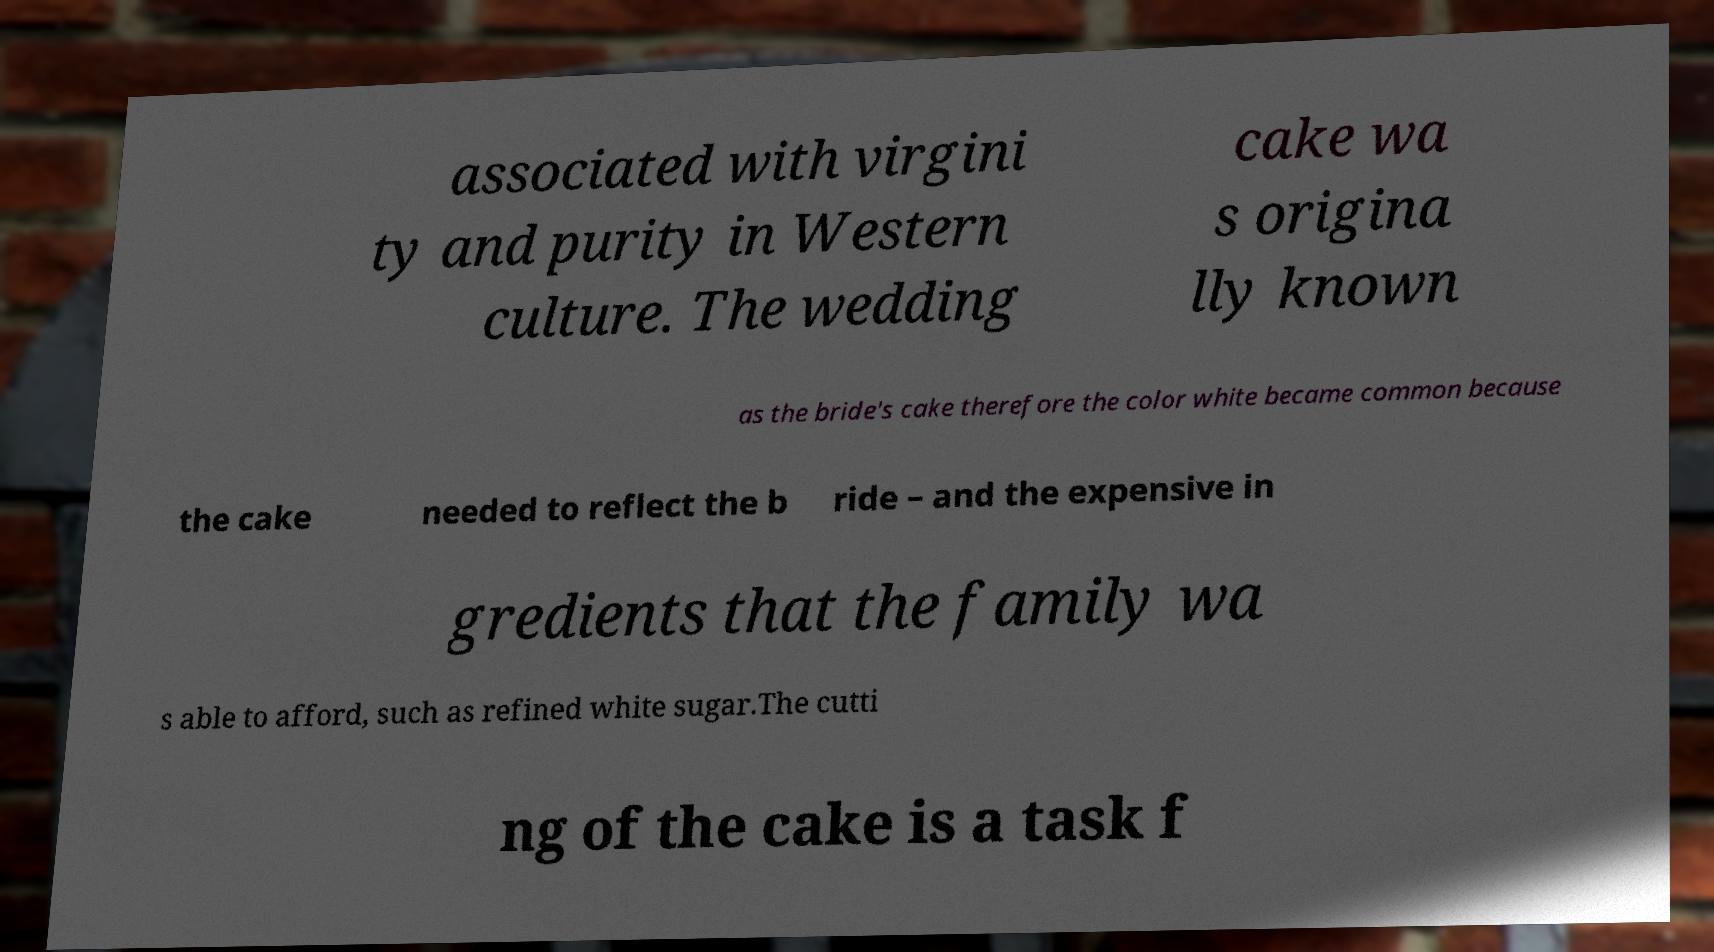For documentation purposes, I need the text within this image transcribed. Could you provide that? associated with virgini ty and purity in Western culture. The wedding cake wa s origina lly known as the bride's cake therefore the color white became common because the cake needed to reflect the b ride – and the expensive in gredients that the family wa s able to afford, such as refined white sugar.The cutti ng of the cake is a task f 